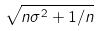Convert formula to latex. <formula><loc_0><loc_0><loc_500><loc_500>\sqrt { n \sigma ^ { 2 } + 1 / n }</formula> 